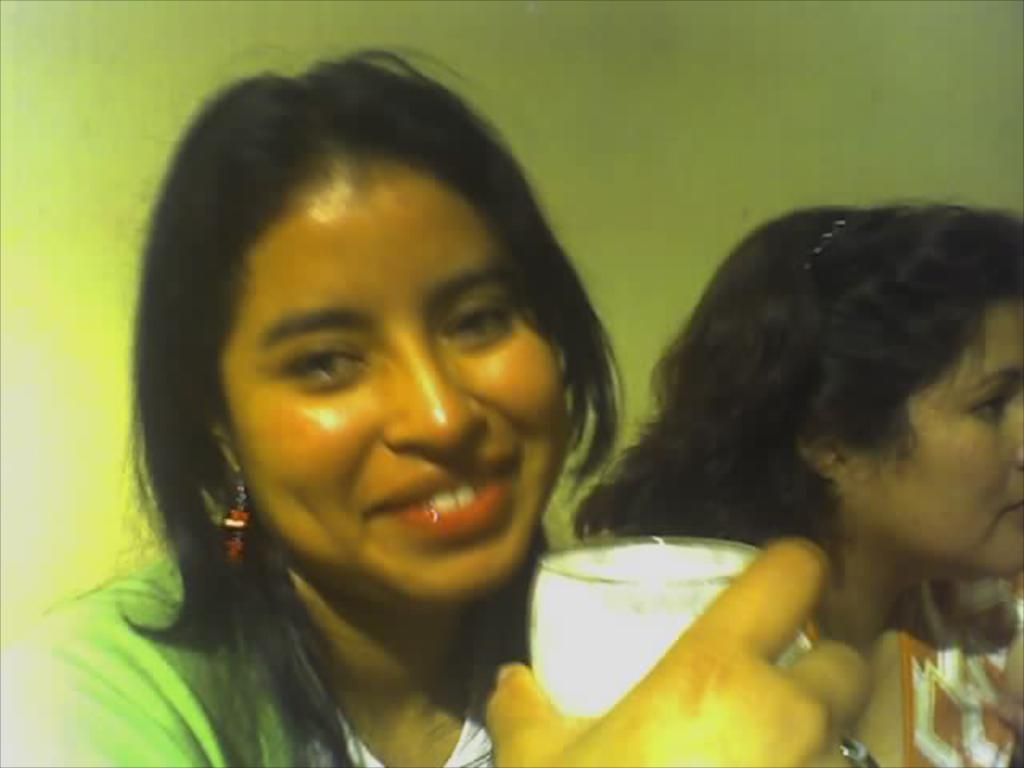How many people are in the image? There are two women in the image. What is one of the women holding? One of the women is holding a glass. What can be seen in the background of the image? There is a wall in the background of the image. What type of toothpaste is the woman using in the image? There is no toothpaste present in the image. What kind of mint is being grown in the image? There is no mint or any produce visible in the image. 